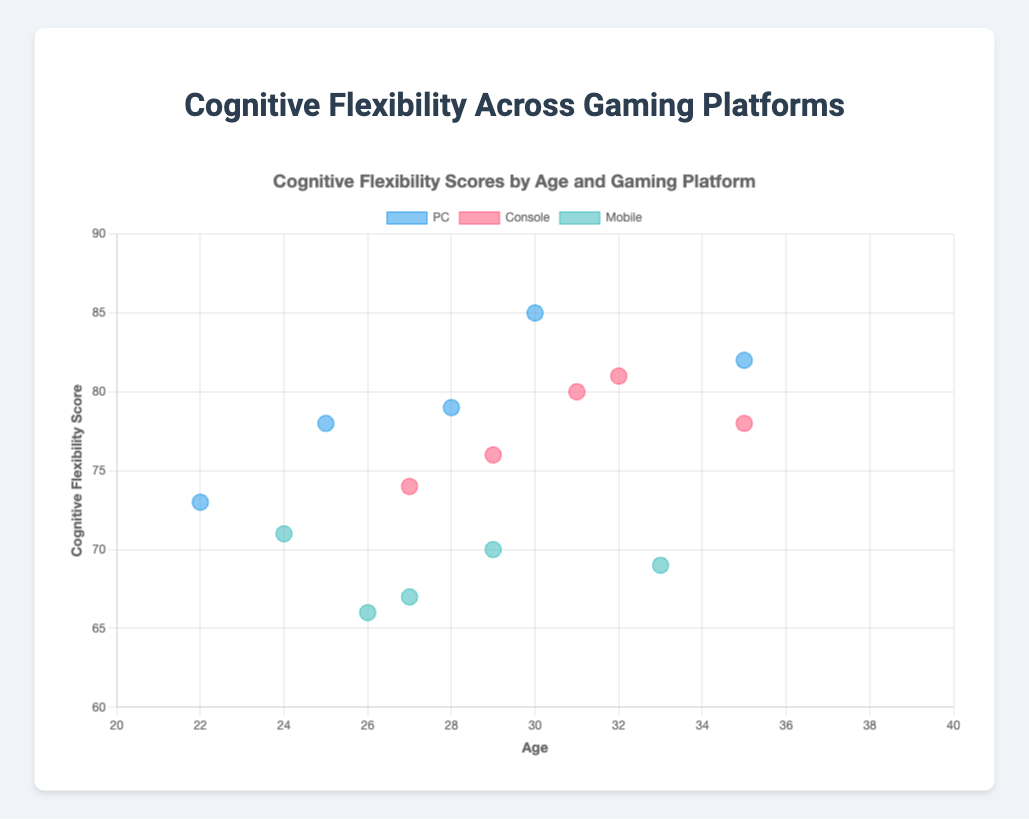How many platforms are represented in the figure? The legend shows three distinct colors representing three platforms: PC, Console, and Mobile.
Answer: Three What is the average Cognitive Flexibility Score for PC users? By summing the scores for PC users (78 + 85 + 73 + 79 + 82), we get 397. Dividing by the number of PC users (5), the average is 397/5.
Answer: 79.4 Which platform has the highest Cognitive Flexibility Score and what is that score? By examining the y-values, the highest score is 85, which is achieved by a PC user.
Answer: PC, 85 How does the Cognitive Flexibility Score for Mobile users compare to Console users? Mobile users' highest score is 71, and the lowest is 66. For Console users, the highest score is 81, and the lowest is 74. Console users generally have higher Cognitive Flexibility Scores than Mobile users.
Answer: Console users have higher scores than Mobile users What is the range of ages for Console users? The ages for Console users are (27, 32, 29, 31, 35). The range can be calculated as the maximum age (35) minus the minimum age (27).
Answer: 8 Are there any visible trends in Cognitive Flexibility Scores based on age? Higher Cognitive Flexibility Scores do not appear to be strongly correlated with age as high and low scores are scattered across the age groups for each platform, suggesting no clear trend.
Answer: No clear trend Which platform has the most consistent Cognitive Flexibility Scores among its users? Assessing the spread of scores by looking at the vertical distribution of points in each color, Console users' scores range from 74 to 81 (a narrow range), indicating consistency.
Answer: Console What is the median Cognitive Flexibility Score for Mobile users? Ordering the Mobile scores (66, 67, 69, 70, 71) and identifying the middle value, the median is 69.
Answer: 69 Who is the oldest user and what is their Cognitive Flexibility Score? The oldest user is 35, and there are users aged 35 in both the PC and Console categories with scores of 82 and 78, respectively.
Answer: PC user, 82 Do users on different platforms tend to have significantly different Cognitive Flexibility Scores? By noting the overall spread and average of data points for each platform, PC users have higher scores on average (78 to 85), Console users are slightly behind (74 to 81), and Mobile users generally score the lowest (66 to 71). This suggests significant differences.
Answer: Yes 